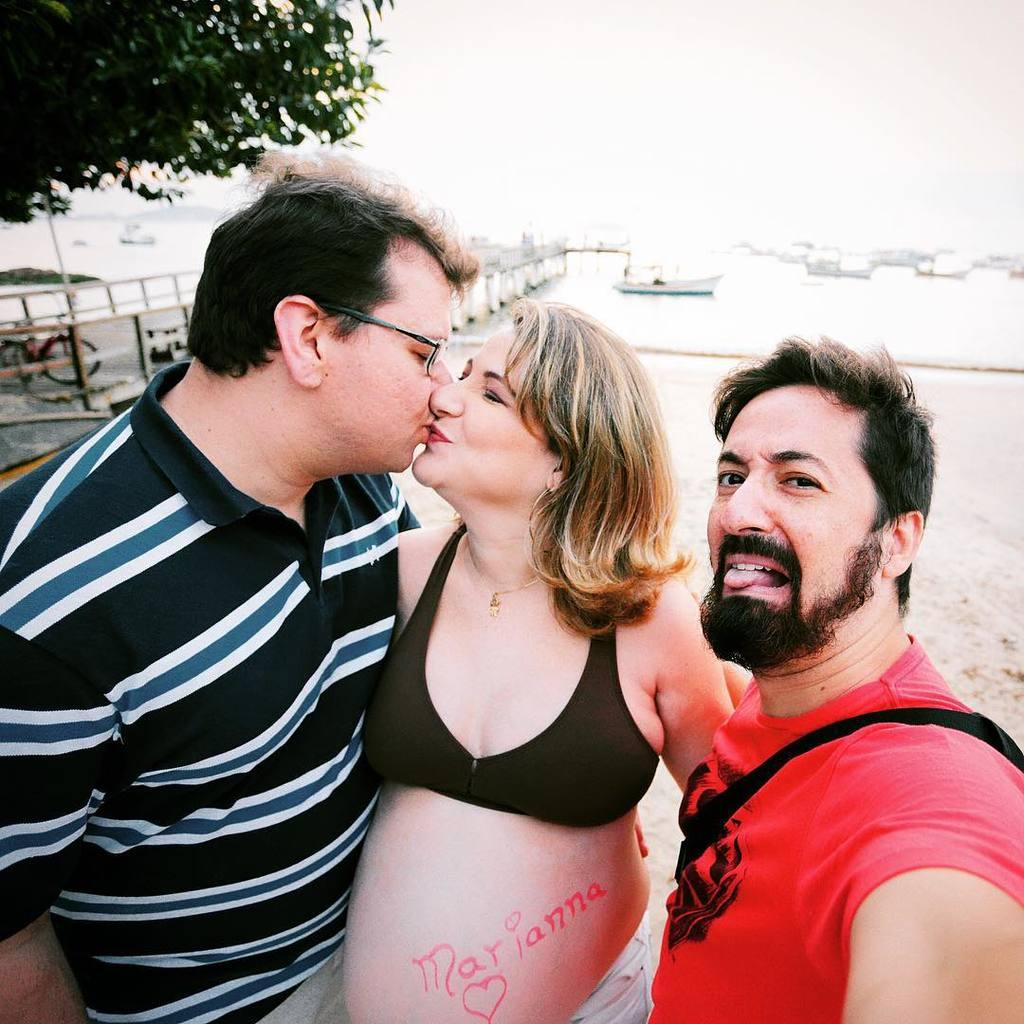How many people are in the image? There are two men and two women in the image, making a total of four people. What is the surface they are standing on? They are standing on the sand. What can be seen in the background of the image? There are boats, the sea, a tree, a bridge, and a cycle visible in the background. What type of clam is being used as a prop in the image? There is no clam present in the image. What is the reason for the protest happening in the background of the image? There is no protest happening in the image; it is a scene of people standing on the sand with various background elements. 